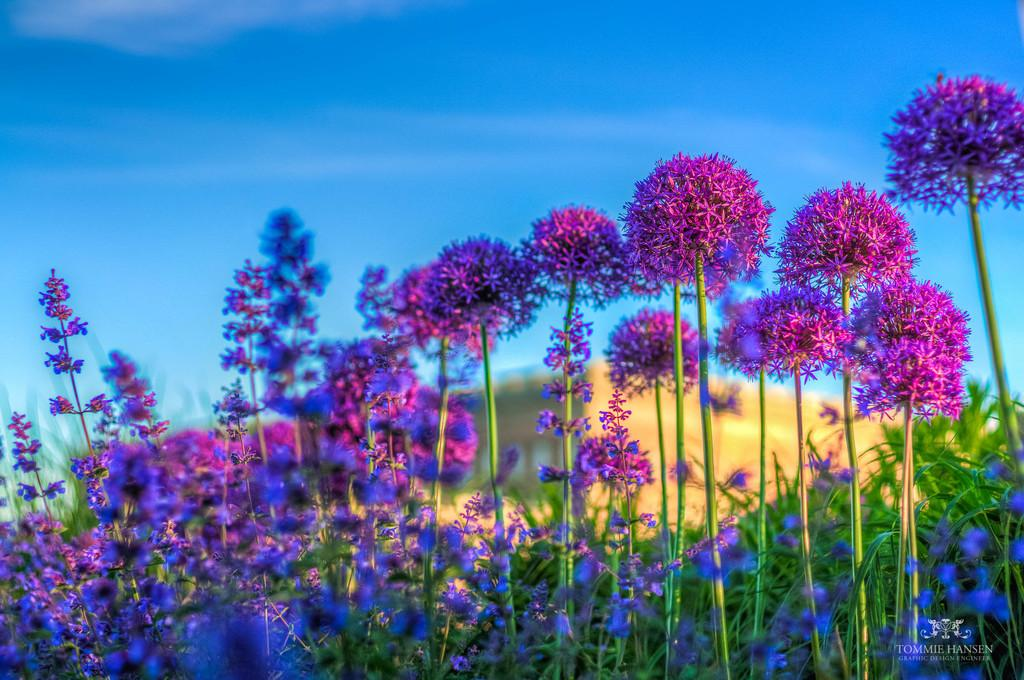What type of living organisms can be seen in the image? There are flowers in the image. What can be seen in the sky in the background of the image? There are clouds in the sky in the background of the image. How many clocks are hanging on the flowers in the image? There are no clocks present in the image; it features flowers and clouds in the sky. What type of toy can be seen interacting with the flowers in the image? There is no toy present in the image; it only features flowers and clouds in the sky. 